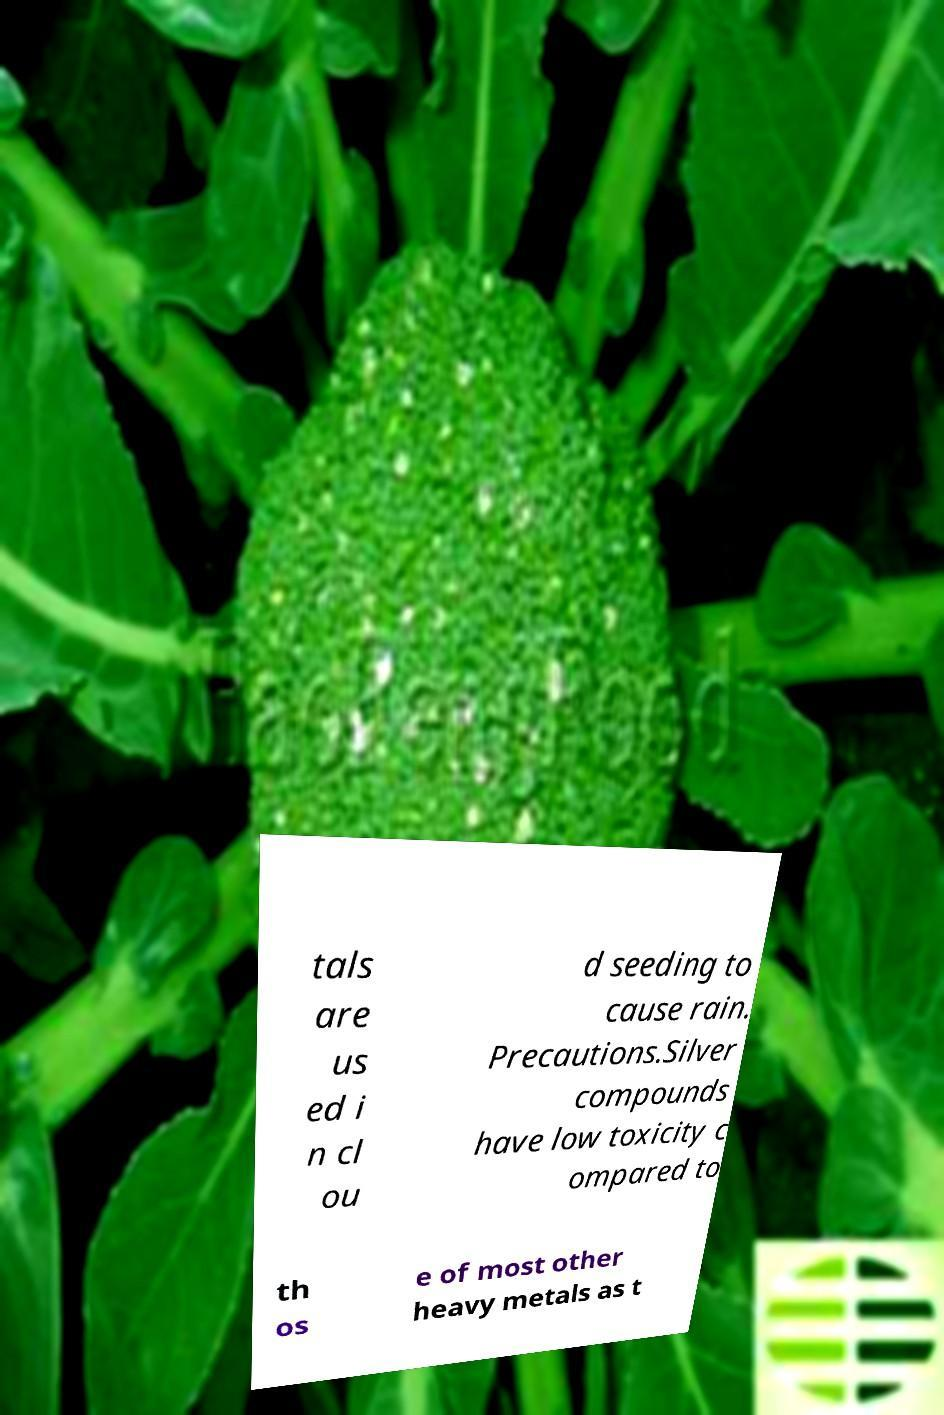Can you read and provide the text displayed in the image?This photo seems to have some interesting text. Can you extract and type it out for me? tals are us ed i n cl ou d seeding to cause rain. Precautions.Silver compounds have low toxicity c ompared to th os e of most other heavy metals as t 